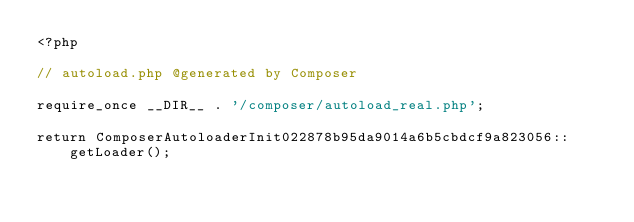Convert code to text. <code><loc_0><loc_0><loc_500><loc_500><_PHP_><?php

// autoload.php @generated by Composer

require_once __DIR__ . '/composer/autoload_real.php';

return ComposerAutoloaderInit022878b95da9014a6b5cbdcf9a823056::getLoader();
</code> 